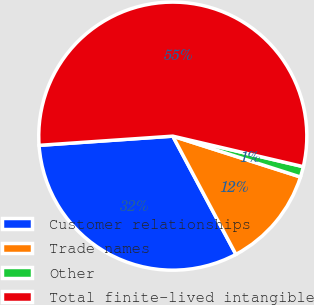<chart> <loc_0><loc_0><loc_500><loc_500><pie_chart><fcel>Customer relationships<fcel>Trade names<fcel>Other<fcel>Total finite-lived intangible<nl><fcel>31.71%<fcel>12.27%<fcel>1.27%<fcel>54.75%<nl></chart> 